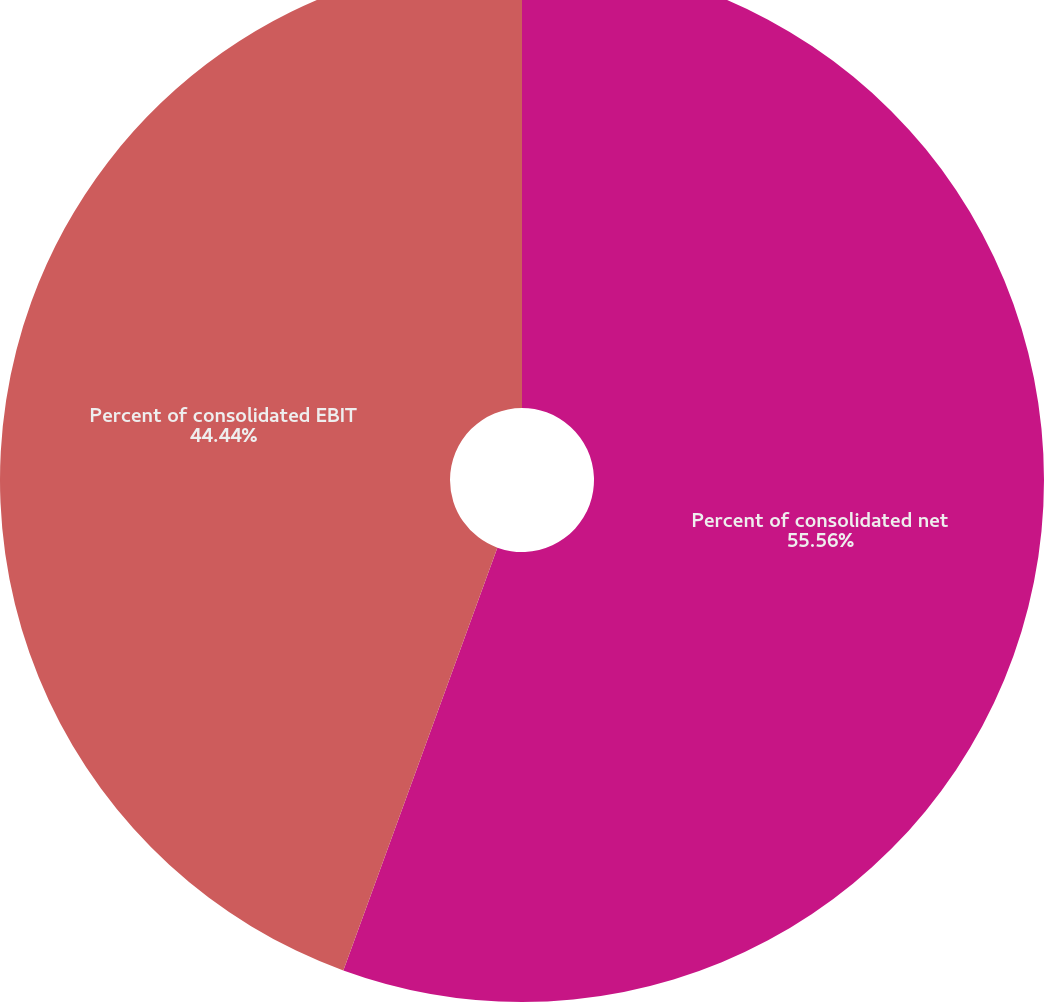<chart> <loc_0><loc_0><loc_500><loc_500><pie_chart><fcel>Percent of consolidated net<fcel>Percent of consolidated EBIT<nl><fcel>55.56%<fcel>44.44%<nl></chart> 